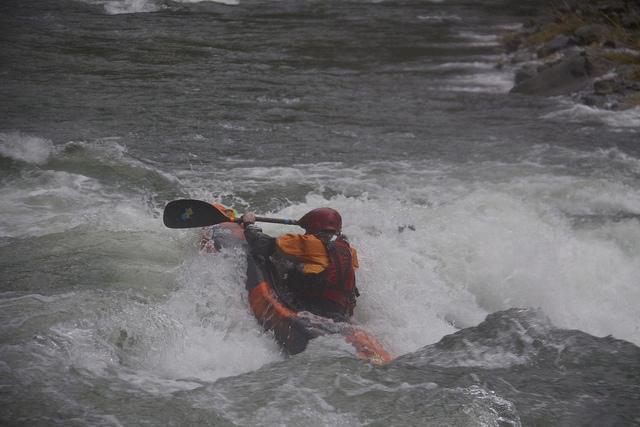What life threatening danger does this kayaker face if the waves get to high?
Choose the right answer from the provided options to respond to the question.
Options: Drowning, burning, electrocution, punch. Drowning. 